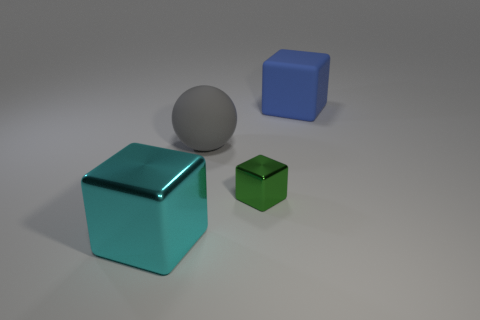There is a block that is the same material as the gray sphere; what color is it?
Your answer should be compact. Blue. Is there anything else that is the same size as the green thing?
Provide a short and direct response. No. How many tiny things are either matte cubes or green blocks?
Provide a short and direct response. 1. Is the number of large metal things less than the number of tiny purple shiny spheres?
Offer a terse response. No. What is the color of the other large shiny object that is the same shape as the large blue object?
Keep it short and to the point. Cyan. Is there anything else that is the same shape as the large cyan metal object?
Provide a succinct answer. Yes. Is the number of tiny green blocks greater than the number of purple cylinders?
Give a very brief answer. Yes. What number of other things are the same material as the small block?
Keep it short and to the point. 1. What shape is the gray matte thing that is behind the large cube left of the large rubber object on the right side of the gray object?
Ensure brevity in your answer.  Sphere. Are there fewer matte blocks that are to the left of the big matte ball than things that are to the left of the tiny green object?
Provide a short and direct response. Yes. 